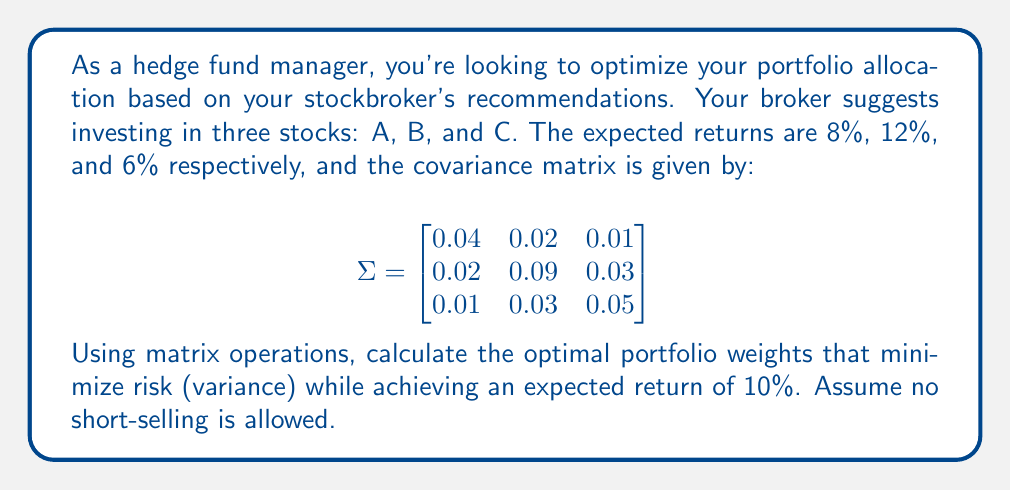What is the answer to this math problem? To solve this problem, we'll use the matrix form of the constrained optimization problem for portfolio allocation. We'll follow these steps:

1) Define the vectors and matrices:
   $\mathbf{r} = [0.08, 0.12, 0.06]^T$ (expected returns)
   $\mathbf{1} = [1, 1, 1]^T$ (vector of ones)
   $\Sigma$ is given in the question (covariance matrix)

2) Set up the augmented matrix for the Lagrangian multipliers:
   $$
   A = \begin{bmatrix}
   2\Sigma & -\mathbf{r} & -\mathbf{1} \\
   \mathbf{r}^T & 0 & 0 \\
   \mathbf{1}^T & 0 & 0
   \end{bmatrix}
   $$

3) Set up the right-hand side vector:
   $\mathbf{b} = [0, 0, 0, 0.10, 1]^T$

4) Solve the system $A\mathbf{x} = \mathbf{b}$ for $\mathbf{x}$:
   $$
   A = \begin{bmatrix}
   0.08 & 0.04 & 0.02 & -0.08 & -1 \\
   0.04 & 0.18 & 0.06 & -0.12 & -1 \\
   0.02 & 0.06 & 0.10 & -0.06 & -1 \\
   0.08 & 0.12 & 0.06 & 0 & 0 \\
   1 & 1 & 1 & 0 & 0
   \end{bmatrix}
   $$

   Solving this system (using a computer or calculator) gives:
   $\mathbf{x} = [0.2857, 0.5714, 0.1429, 0.0286, -0.0014]^T$

5) The first three elements of $\mathbf{x}$ are the optimal portfolio weights.

Therefore, the optimal portfolio allocation is:
Stock A: 28.57%
Stock B: 57.14%
Stock C: 14.29%
Answer: [0.2857, 0.5714, 0.1429] 